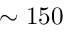<formula> <loc_0><loc_0><loc_500><loc_500>\sim 1 5 0</formula> 